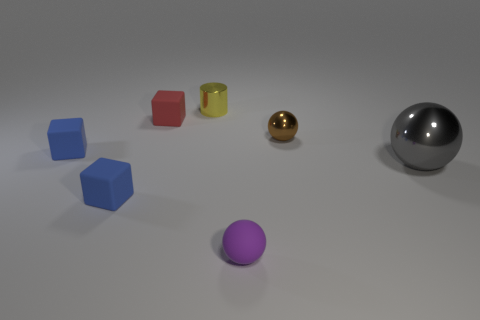Are there fewer big objects than small blue rubber blocks?
Ensure brevity in your answer.  Yes. There is a small brown metallic thing; are there any small brown metallic things on the right side of it?
Offer a very short reply. No. What shape is the metal object that is both right of the small purple ball and behind the gray object?
Your response must be concise. Sphere. Is there a tiny purple rubber thing of the same shape as the large shiny object?
Offer a very short reply. Yes. Is the size of the metal object to the left of the purple matte sphere the same as the rubber thing that is to the right of the yellow object?
Offer a very short reply. Yes. Are there more brown balls than large cyan metallic cylinders?
Your answer should be very brief. Yes. How many other gray things have the same material as the large thing?
Make the answer very short. 0. Does the small yellow shiny thing have the same shape as the gray thing?
Provide a short and direct response. No. There is a metallic ball that is right of the tiny shiny object that is to the right of the tiny object behind the red rubber cube; what is its size?
Offer a very short reply. Large. Are there any small purple balls that are to the left of the small object behind the red object?
Provide a short and direct response. No. 